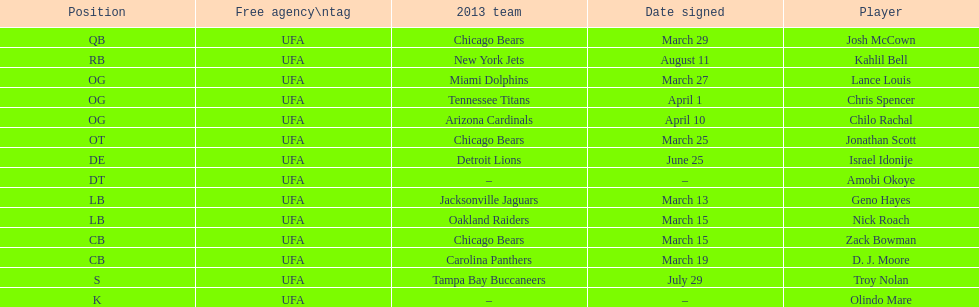How many free agents did this team pick up this season? 14. 